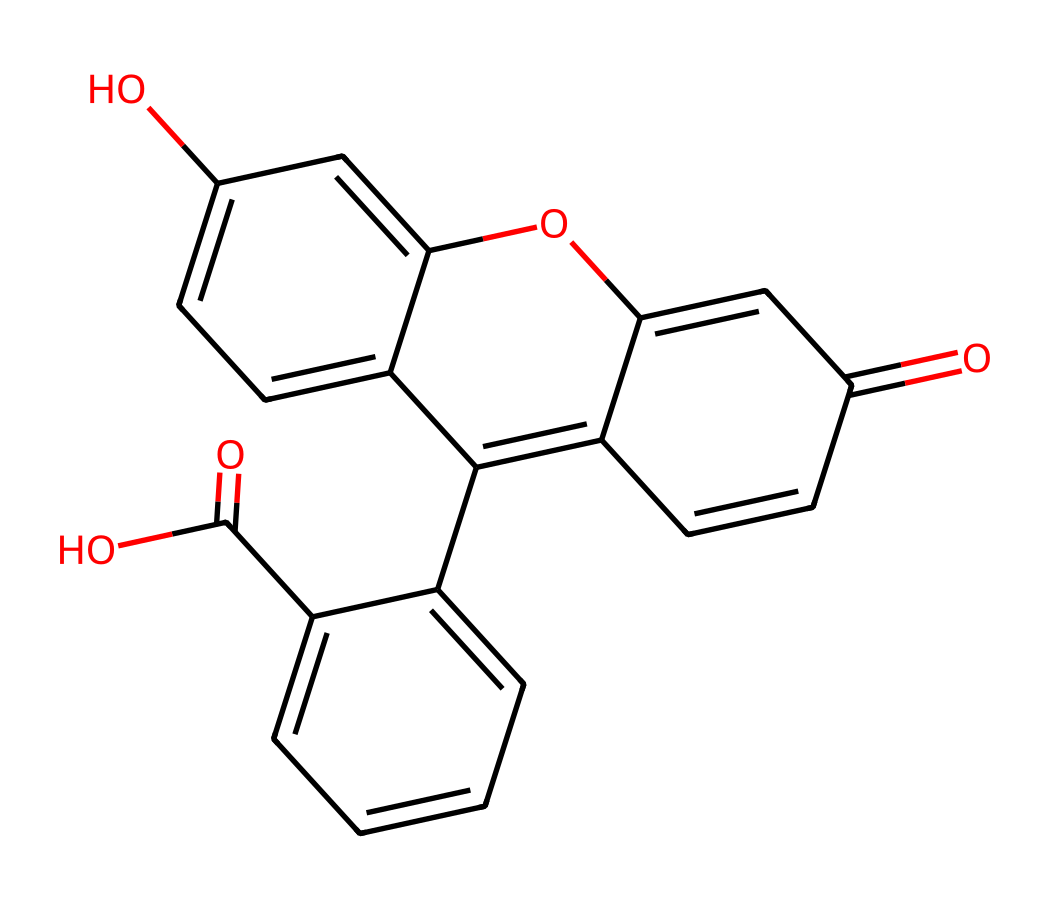What is the molecular formula of fluorescein? To determine the molecular formula, count the number of each type of atom present in the structure based on its SMILES representation. The chemical structure contains 21 carbon atoms, 18 hydrogen atoms, 5 oxygen atoms. Thus, the molecular formula is C21H18O5.
Answer: C21H18O5 How many rings are present in fluorescein's structure? The structure depicts two interconnected cyclic (ring) structures. Both parts of the molecule contribute to the ring count, resulting in a total of two rings.
Answer: 2 What is the primary functional group in fluorescein? Analyzing the structure, it contains carboxylic acid groups (-COOH) and hydroxyl groups (-OH), but the prominent functional group that defines it is the hydroxyl (alcohol) group, which is commonly associated with its fluorescent properties.
Answer: hydroxyl Is fluorescein soluble in water? Fluorescein has multiple hydroxyl groups which enhance its interaction with water molecules, contributing to its solubility in aqueous solutions. Therefore, fluorescein is known to be soluble in water.
Answer: soluble What property makes fluorescein photoreactive? The presence of conjugated double bonds within its structure allows for the electronic excitation upon absorption of specific wavelengths of light, resulting in fluorescence. This conjugation is a key aspect of its photoreactivity.
Answer: conjugated double bonds How does fluorescein help in water tracing during storm events? Fluorescein’s fluorescence allows for easy detection in water, making it a valuable tracer during storm events to track water flow and pollution dispersal in real-time.
Answer: fluorescence 